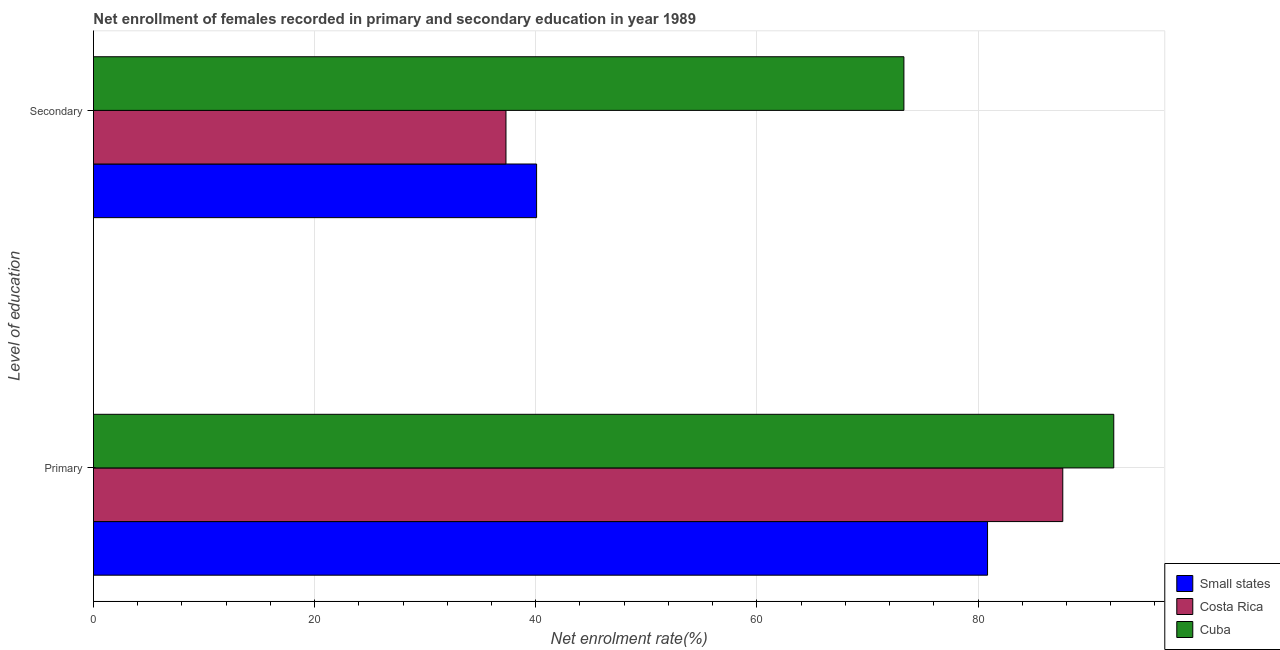How many different coloured bars are there?
Keep it short and to the point. 3. How many groups of bars are there?
Provide a succinct answer. 2. Are the number of bars per tick equal to the number of legend labels?
Provide a short and direct response. Yes. Are the number of bars on each tick of the Y-axis equal?
Keep it short and to the point. Yes. How many bars are there on the 2nd tick from the bottom?
Provide a short and direct response. 3. What is the label of the 2nd group of bars from the top?
Your answer should be very brief. Primary. What is the enrollment rate in secondary education in Small states?
Your answer should be compact. 40.08. Across all countries, what is the maximum enrollment rate in primary education?
Your answer should be very brief. 92.28. Across all countries, what is the minimum enrollment rate in primary education?
Offer a terse response. 80.86. In which country was the enrollment rate in primary education maximum?
Ensure brevity in your answer.  Cuba. What is the total enrollment rate in secondary education in the graph?
Offer a very short reply. 150.68. What is the difference between the enrollment rate in primary education in Small states and that in Costa Rica?
Give a very brief answer. -6.8. What is the difference between the enrollment rate in secondary education in Cuba and the enrollment rate in primary education in Small states?
Your answer should be very brief. -7.57. What is the average enrollment rate in secondary education per country?
Provide a short and direct response. 50.23. What is the difference between the enrollment rate in secondary education and enrollment rate in primary education in Small states?
Keep it short and to the point. -40.79. What is the ratio of the enrollment rate in primary education in Small states to that in Costa Rica?
Offer a very short reply. 0.92. What does the 3rd bar from the top in Secondary represents?
Your response must be concise. Small states. What does the 1st bar from the bottom in Primary represents?
Keep it short and to the point. Small states. What is the difference between two consecutive major ticks on the X-axis?
Offer a very short reply. 20. Are the values on the major ticks of X-axis written in scientific E-notation?
Ensure brevity in your answer.  No. Does the graph contain any zero values?
Provide a succinct answer. No. How many legend labels are there?
Provide a short and direct response. 3. What is the title of the graph?
Ensure brevity in your answer.  Net enrollment of females recorded in primary and secondary education in year 1989. What is the label or title of the X-axis?
Offer a very short reply. Net enrolment rate(%). What is the label or title of the Y-axis?
Provide a short and direct response. Level of education. What is the Net enrolment rate(%) in Small states in Primary?
Offer a terse response. 80.86. What is the Net enrolment rate(%) of Costa Rica in Primary?
Provide a succinct answer. 87.67. What is the Net enrolment rate(%) in Cuba in Primary?
Your response must be concise. 92.28. What is the Net enrolment rate(%) in Small states in Secondary?
Your answer should be compact. 40.08. What is the Net enrolment rate(%) in Costa Rica in Secondary?
Your answer should be very brief. 37.31. What is the Net enrolment rate(%) in Cuba in Secondary?
Offer a terse response. 73.3. Across all Level of education, what is the maximum Net enrolment rate(%) of Small states?
Provide a short and direct response. 80.86. Across all Level of education, what is the maximum Net enrolment rate(%) in Costa Rica?
Keep it short and to the point. 87.67. Across all Level of education, what is the maximum Net enrolment rate(%) of Cuba?
Your response must be concise. 92.28. Across all Level of education, what is the minimum Net enrolment rate(%) of Small states?
Ensure brevity in your answer.  40.08. Across all Level of education, what is the minimum Net enrolment rate(%) in Costa Rica?
Offer a terse response. 37.31. Across all Level of education, what is the minimum Net enrolment rate(%) of Cuba?
Offer a terse response. 73.3. What is the total Net enrolment rate(%) in Small states in the graph?
Offer a very short reply. 120.94. What is the total Net enrolment rate(%) of Costa Rica in the graph?
Provide a short and direct response. 124.97. What is the total Net enrolment rate(%) of Cuba in the graph?
Your response must be concise. 165.57. What is the difference between the Net enrolment rate(%) in Small states in Primary and that in Secondary?
Offer a terse response. 40.79. What is the difference between the Net enrolment rate(%) of Costa Rica in Primary and that in Secondary?
Offer a terse response. 50.36. What is the difference between the Net enrolment rate(%) in Cuba in Primary and that in Secondary?
Provide a short and direct response. 18.98. What is the difference between the Net enrolment rate(%) in Small states in Primary and the Net enrolment rate(%) in Costa Rica in Secondary?
Offer a very short reply. 43.56. What is the difference between the Net enrolment rate(%) in Small states in Primary and the Net enrolment rate(%) in Cuba in Secondary?
Provide a short and direct response. 7.57. What is the difference between the Net enrolment rate(%) in Costa Rica in Primary and the Net enrolment rate(%) in Cuba in Secondary?
Provide a succinct answer. 14.37. What is the average Net enrolment rate(%) in Small states per Level of education?
Make the answer very short. 60.47. What is the average Net enrolment rate(%) of Costa Rica per Level of education?
Give a very brief answer. 62.49. What is the average Net enrolment rate(%) of Cuba per Level of education?
Provide a short and direct response. 82.79. What is the difference between the Net enrolment rate(%) of Small states and Net enrolment rate(%) of Costa Rica in Primary?
Offer a terse response. -6.8. What is the difference between the Net enrolment rate(%) of Small states and Net enrolment rate(%) of Cuba in Primary?
Make the answer very short. -11.41. What is the difference between the Net enrolment rate(%) of Costa Rica and Net enrolment rate(%) of Cuba in Primary?
Keep it short and to the point. -4.61. What is the difference between the Net enrolment rate(%) in Small states and Net enrolment rate(%) in Costa Rica in Secondary?
Offer a terse response. 2.77. What is the difference between the Net enrolment rate(%) in Small states and Net enrolment rate(%) in Cuba in Secondary?
Make the answer very short. -33.22. What is the difference between the Net enrolment rate(%) in Costa Rica and Net enrolment rate(%) in Cuba in Secondary?
Offer a terse response. -35.99. What is the ratio of the Net enrolment rate(%) in Small states in Primary to that in Secondary?
Make the answer very short. 2.02. What is the ratio of the Net enrolment rate(%) in Costa Rica in Primary to that in Secondary?
Make the answer very short. 2.35. What is the ratio of the Net enrolment rate(%) in Cuba in Primary to that in Secondary?
Your response must be concise. 1.26. What is the difference between the highest and the second highest Net enrolment rate(%) in Small states?
Make the answer very short. 40.79. What is the difference between the highest and the second highest Net enrolment rate(%) in Costa Rica?
Your answer should be compact. 50.36. What is the difference between the highest and the second highest Net enrolment rate(%) of Cuba?
Provide a succinct answer. 18.98. What is the difference between the highest and the lowest Net enrolment rate(%) of Small states?
Provide a succinct answer. 40.79. What is the difference between the highest and the lowest Net enrolment rate(%) in Costa Rica?
Give a very brief answer. 50.36. What is the difference between the highest and the lowest Net enrolment rate(%) in Cuba?
Your answer should be very brief. 18.98. 